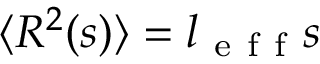<formula> <loc_0><loc_0><loc_500><loc_500>\langle R ^ { 2 } ( s ) \rangle = l _ { e f f } s</formula> 